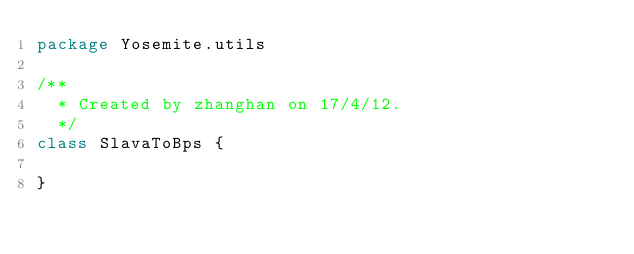<code> <loc_0><loc_0><loc_500><loc_500><_Scala_>package Yosemite.utils

/**
  * Created by zhanghan on 17/4/12.
  */
class SlavaToBps {

}
</code> 